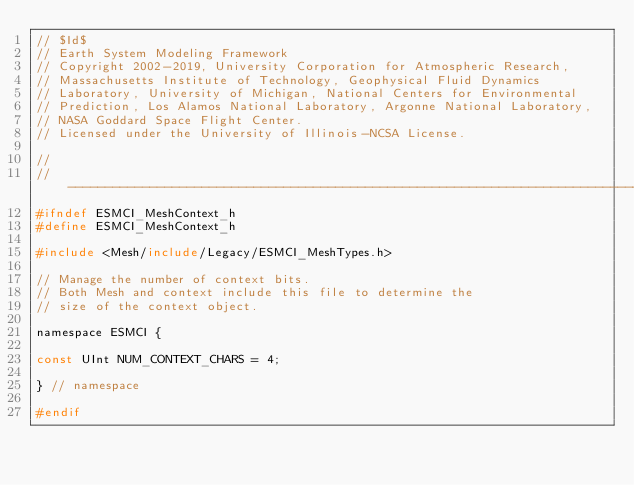<code> <loc_0><loc_0><loc_500><loc_500><_C_>// $Id$
// Earth System Modeling Framework
// Copyright 2002-2019, University Corporation for Atmospheric Research, 
// Massachusetts Institute of Technology, Geophysical Fluid Dynamics 
// Laboratory, University of Michigan, National Centers for Environmental 
// Prediction, Los Alamos National Laboratory, Argonne National Laboratory, 
// NASA Goddard Space Flight Center.
// Licensed under the University of Illinois-NCSA License.

//
//-----------------------------------------------------------------------------
#ifndef ESMCI_MeshContext_h
#define ESMCI_MeshContext_h

#include <Mesh/include/Legacy/ESMCI_MeshTypes.h>

// Manage the number of context bits.
// Both Mesh and context include this file to determine the
// size of the context object.

namespace ESMCI {

const UInt NUM_CONTEXT_CHARS = 4;

} // namespace

#endif
</code> 